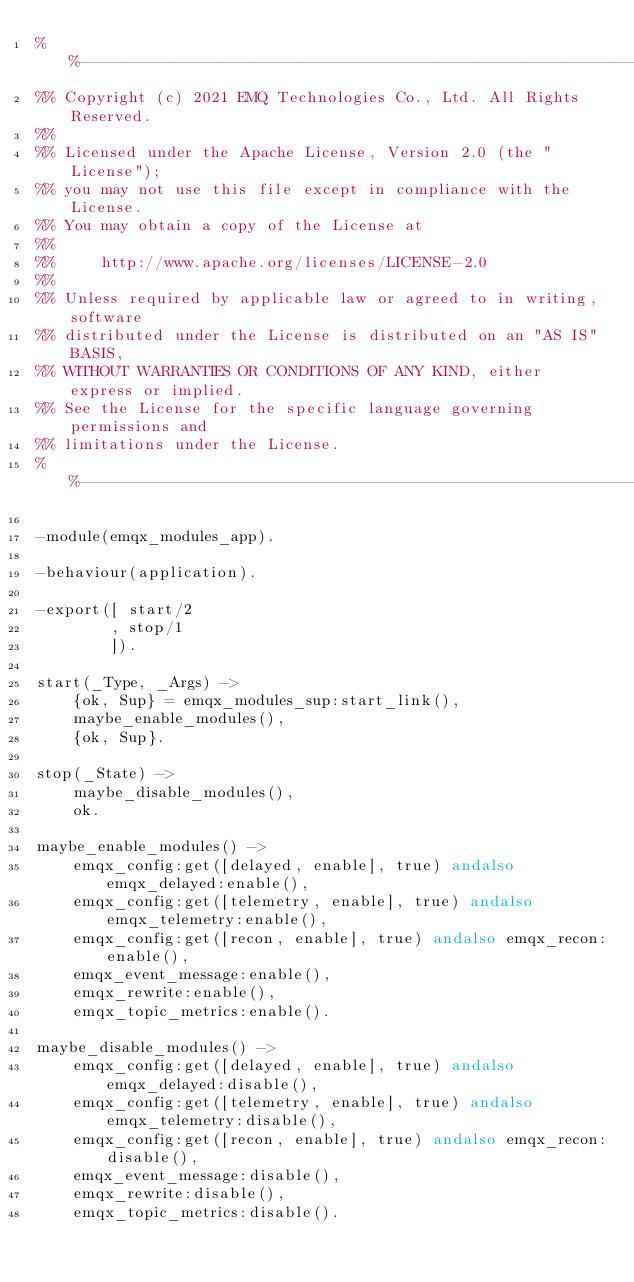Convert code to text. <code><loc_0><loc_0><loc_500><loc_500><_Erlang_>%%--------------------------------------------------------------------
%% Copyright (c) 2021 EMQ Technologies Co., Ltd. All Rights Reserved.
%%
%% Licensed under the Apache License, Version 2.0 (the "License");
%% you may not use this file except in compliance with the License.
%% You may obtain a copy of the License at
%%
%%     http://www.apache.org/licenses/LICENSE-2.0
%%
%% Unless required by applicable law or agreed to in writing, software
%% distributed under the License is distributed on an "AS IS" BASIS,
%% WITHOUT WARRANTIES OR CONDITIONS OF ANY KIND, either express or implied.
%% See the License for the specific language governing permissions and
%% limitations under the License.
%%--------------------------------------------------------------------

-module(emqx_modules_app).

-behaviour(application).

-export([ start/2
        , stop/1
        ]).

start(_Type, _Args) ->
    {ok, Sup} = emqx_modules_sup:start_link(),
    maybe_enable_modules(),
    {ok, Sup}.

stop(_State) ->
    maybe_disable_modules(),
    ok.

maybe_enable_modules() ->
    emqx_config:get([delayed, enable], true) andalso emqx_delayed:enable(),
    emqx_config:get([telemetry, enable], true) andalso emqx_telemetry:enable(),
    emqx_config:get([recon, enable], true) andalso emqx_recon:enable(),
    emqx_event_message:enable(),
    emqx_rewrite:enable(),
    emqx_topic_metrics:enable().

maybe_disable_modules() ->
    emqx_config:get([delayed, enable], true) andalso emqx_delayed:disable(),
    emqx_config:get([telemetry, enable], true) andalso emqx_telemetry:disable(),
    emqx_config:get([recon, enable], true) andalso emqx_recon:disable(),
    emqx_event_message:disable(),
    emqx_rewrite:disable(),
    emqx_topic_metrics:disable().
</code> 